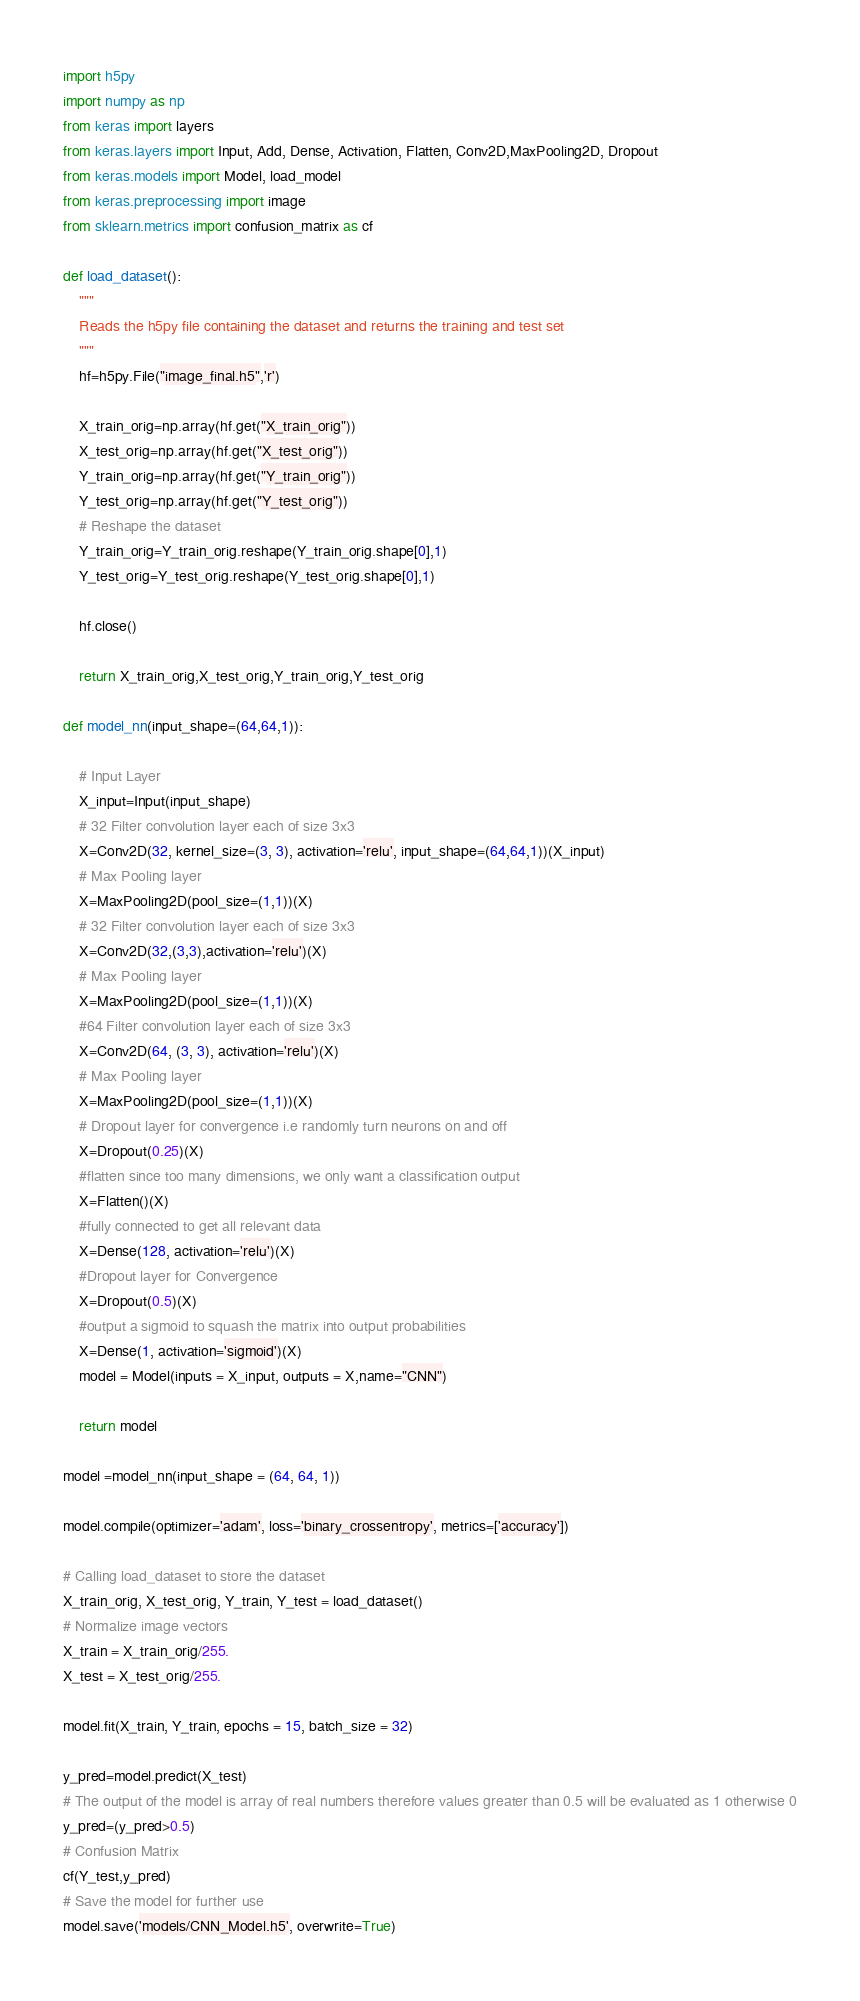<code> <loc_0><loc_0><loc_500><loc_500><_Python_>import h5py
import numpy as np
from keras import layers
from keras.layers import Input, Add, Dense, Activation, Flatten, Conv2D,MaxPooling2D, Dropout
from keras.models import Model, load_model
from keras.preprocessing import image
from sklearn.metrics import confusion_matrix as cf

def load_dataset():
    """
    Reads the h5py file containing the dataset and returns the training and test set
    """
    hf=h5py.File("image_final.h5",'r')

    X_train_orig=np.array(hf.get("X_train_orig"))
    X_test_orig=np.array(hf.get("X_test_orig"))
    Y_train_orig=np.array(hf.get("Y_train_orig"))
    Y_test_orig=np.array(hf.get("Y_test_orig"))
    # Reshape the dataset 
    Y_train_orig=Y_train_orig.reshape(Y_train_orig.shape[0],1)
    Y_test_orig=Y_test_orig.reshape(Y_test_orig.shape[0],1)

    hf.close()

    return X_train_orig,X_test_orig,Y_train_orig,Y_test_orig

def model_nn(input_shape=(64,64,1)):
    
    # Input Layer
	X_input=Input(input_shape)
	# 32 Filter convolution layer each of size 3x3
	X=Conv2D(32, kernel_size=(3, 3), activation='relu', input_shape=(64,64,1))(X_input)
	# Max Pooling layer
	X=MaxPooling2D(pool_size=(1,1))(X)
	# 32 Filter convolution layer each of size 3x3
	X=Conv2D(32,(3,3),activation='relu')(X)
	# Max Pooling layer
	X=MaxPooling2D(pool_size=(1,1))(X)
	#64 Filter convolution layer each of size 3x3
	X=Conv2D(64, (3, 3), activation='relu')(X)
	# Max Pooling layer
	X=MaxPooling2D(pool_size=(1,1))(X)
	# Dropout layer for convergence i.e randomly turn neurons on and off
	X=Dropout(0.25)(X)
	#flatten since too many dimensions, we only want a classification output
	X=Flatten()(X)
	#fully connected to get all relevant data
	X=Dense(128, activation='relu')(X)
	#Dropout layer for Convergence
	X=Dropout(0.5)(X)
	#output a sigmoid to squash the matrix into output probabilities
	X=Dense(1, activation='sigmoid')(X)
	model = Model(inputs = X_input, outputs = X,name="CNN")
    
	return model

model =model_nn(input_shape = (64, 64, 1))

model.compile(optimizer='adam', loss='binary_crossentropy', metrics=['accuracy'])

# Calling load_dataset to store the dataset
X_train_orig, X_test_orig, Y_train, Y_test = load_dataset()
# Normalize image vectors
X_train = X_train_orig/255.
X_test = X_test_orig/255.

model.fit(X_train, Y_train, epochs = 15, batch_size = 32)

y_pred=model.predict(X_test)
# The output of the model is array of real numbers therefore values greater than 0.5 will be evaluated as 1 otherwise 0
y_pred=(y_pred>0.5)
# Confusion Matrix
cf(Y_test,y_pred)
# Save the model for further use
model.save('models/CNN_Model.h5', overwrite=True)


</code> 